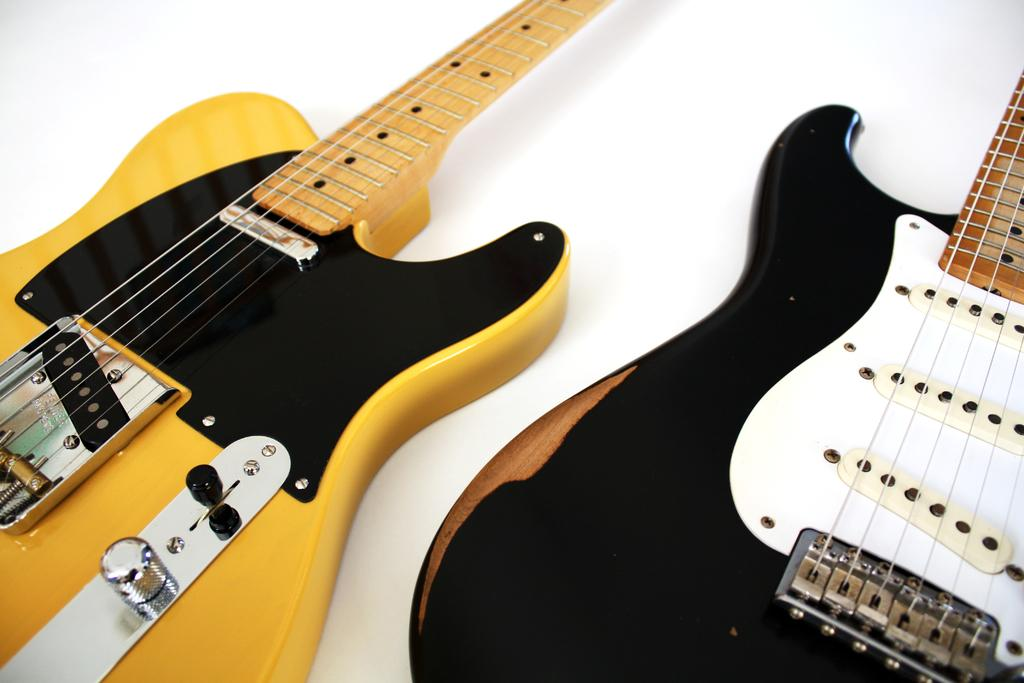How many guitars are in the image? There are two guitars in the image. Can you describe the colors of the guitars? One guitar is white and black in color, and another guitar is yellow and black in color. What is the background color of the image? The background of the image is white. What type of glove is being worn by the person playing the yellow and black guitar in the image? There is no person visible in the image, and therefore no glove can be seen. Is there a volleyball court in the background of the image? There is no volleyball court present in the image; the background is white. 